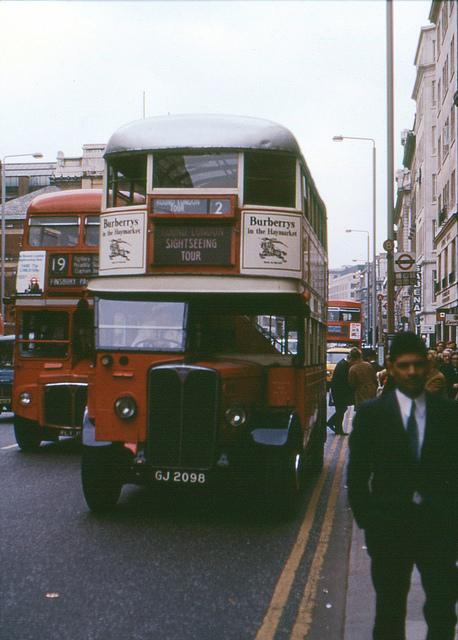Which country were we probably likely to see these old double decker buses? Please explain your reasoning. uk. The country is the uk. 